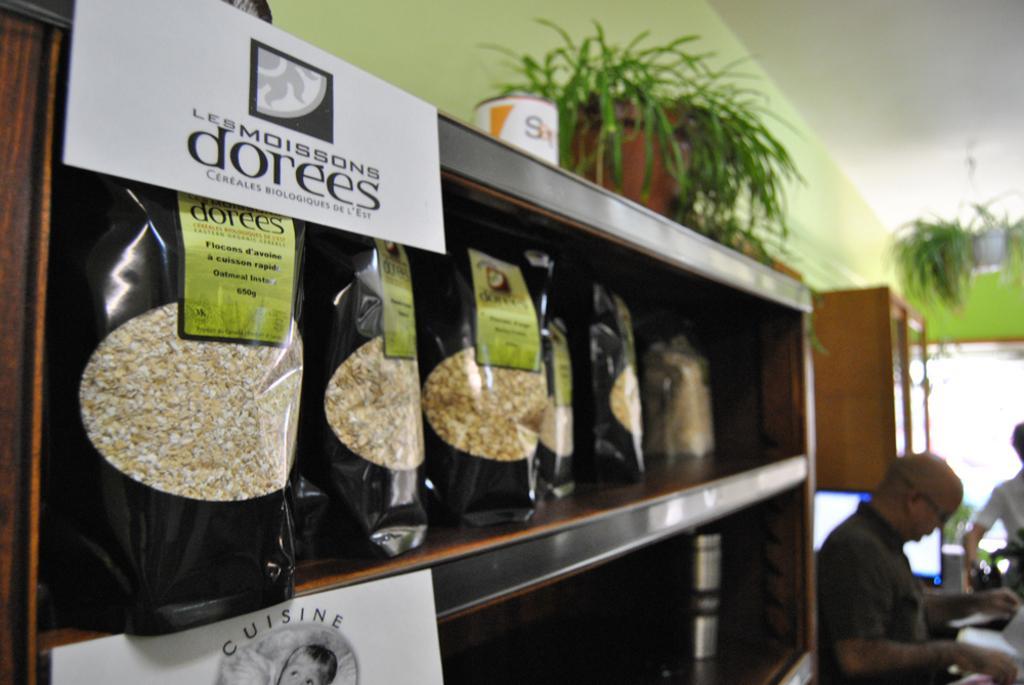Please provide a concise description of this image. In the image we can see there are people standing and there are packets kept on the rack. 